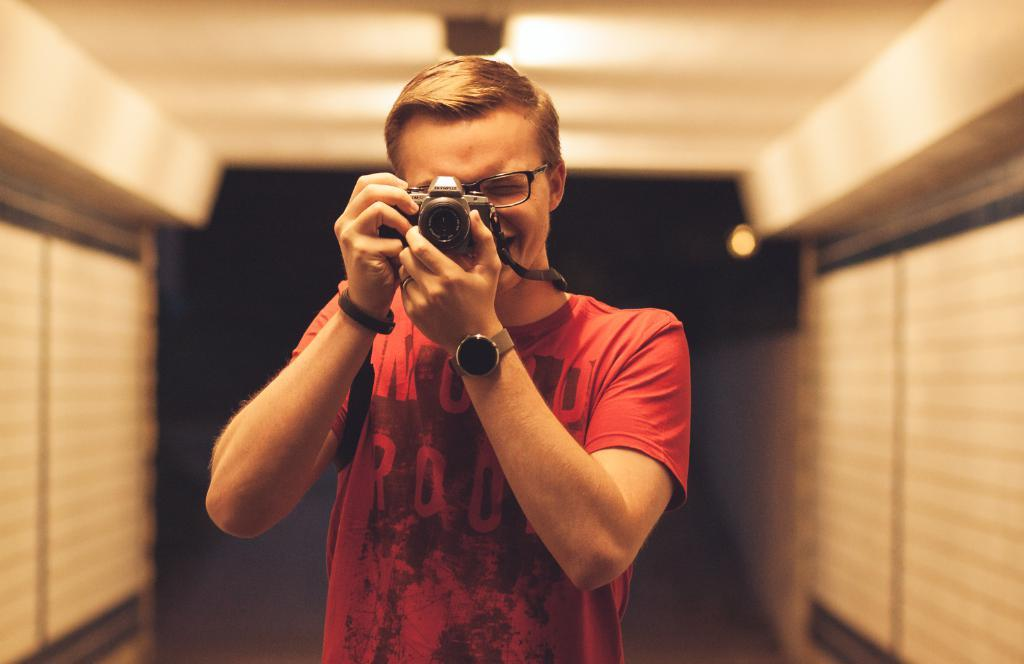Who is the main subject in the image? There is a man in the image. What is the man doing in the image? The man is holding a camera with both hands. What is the man's facial expression in the image? The man is smiling. What can be seen in the background of the image? There is a wall in the background of the image. What type of sign is the man holding in the image? There is no sign present in the image; the man is holding a camera. What musical instrument is the man playing in the image? There is no musical instrument present in the image; the man is holding a camera. 